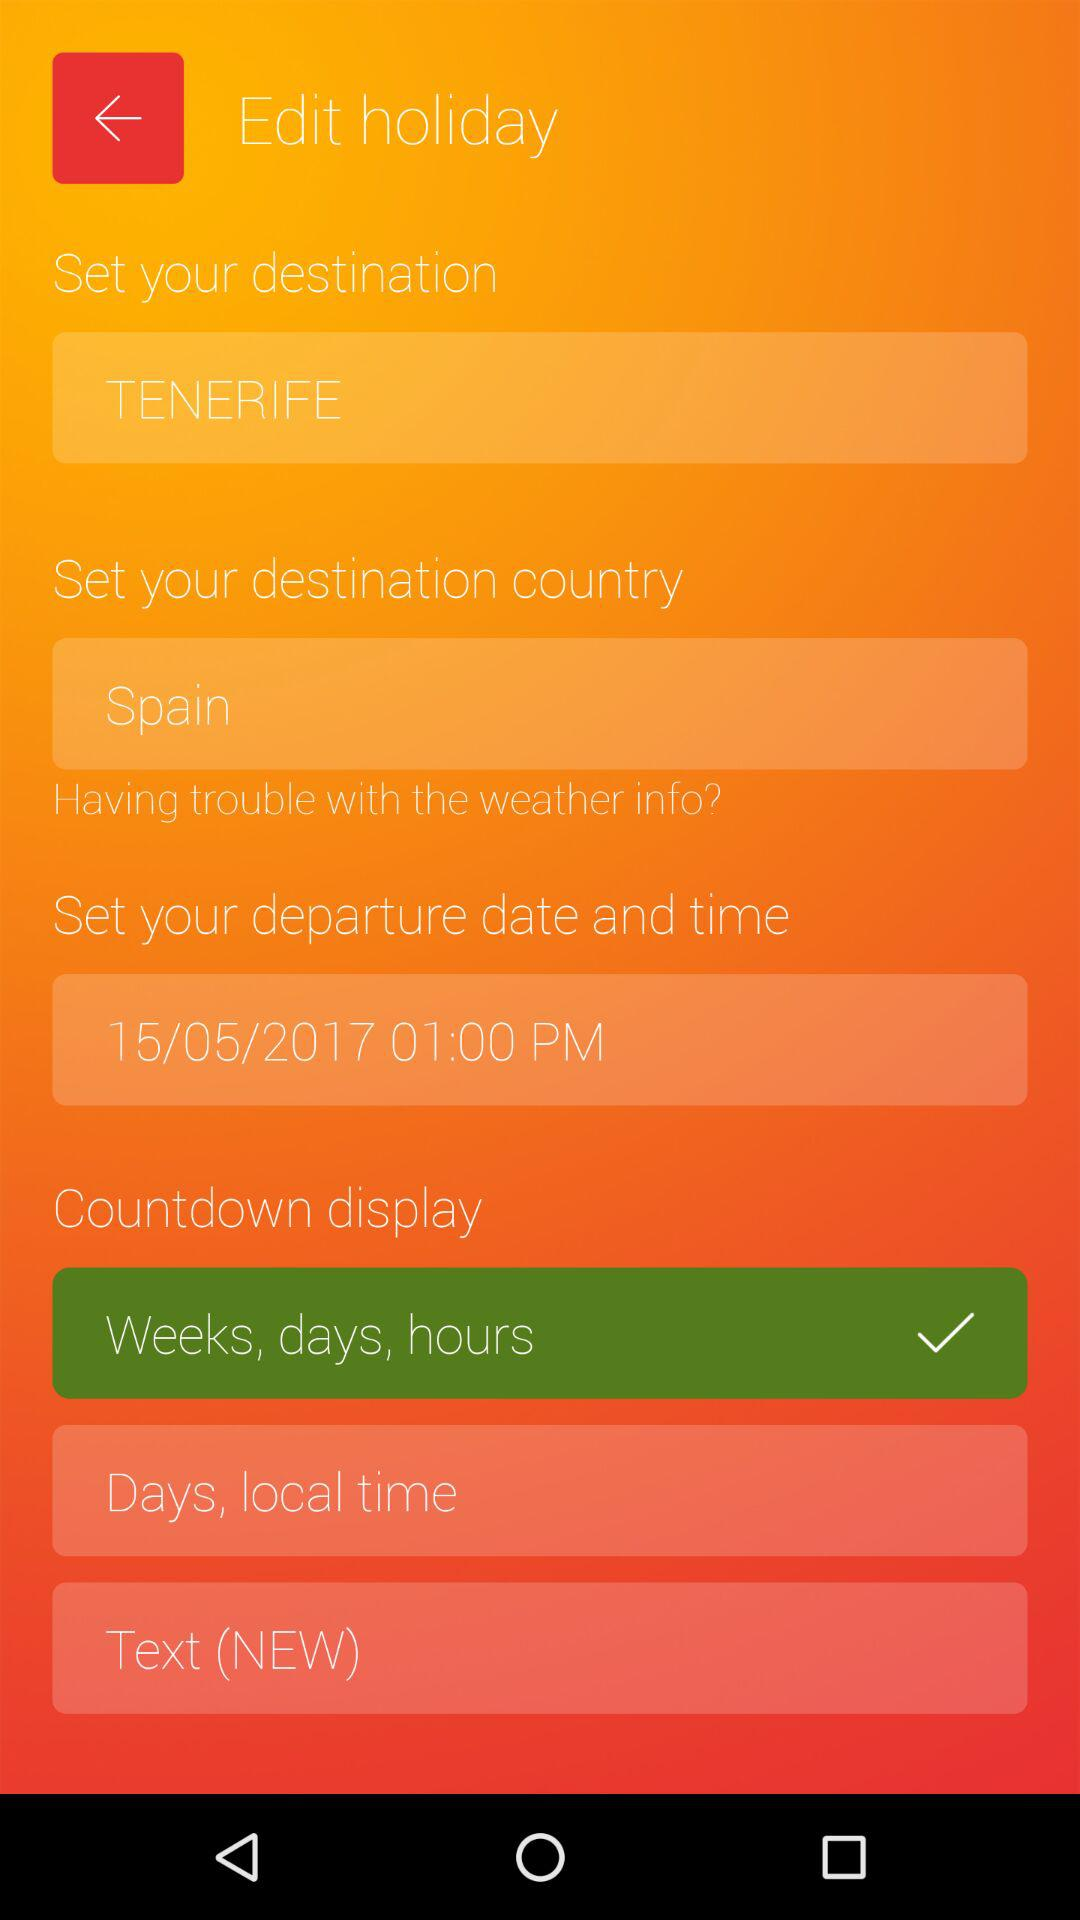What is the selected countdown display? The selected countdown display is "Weeks, days, hours". 